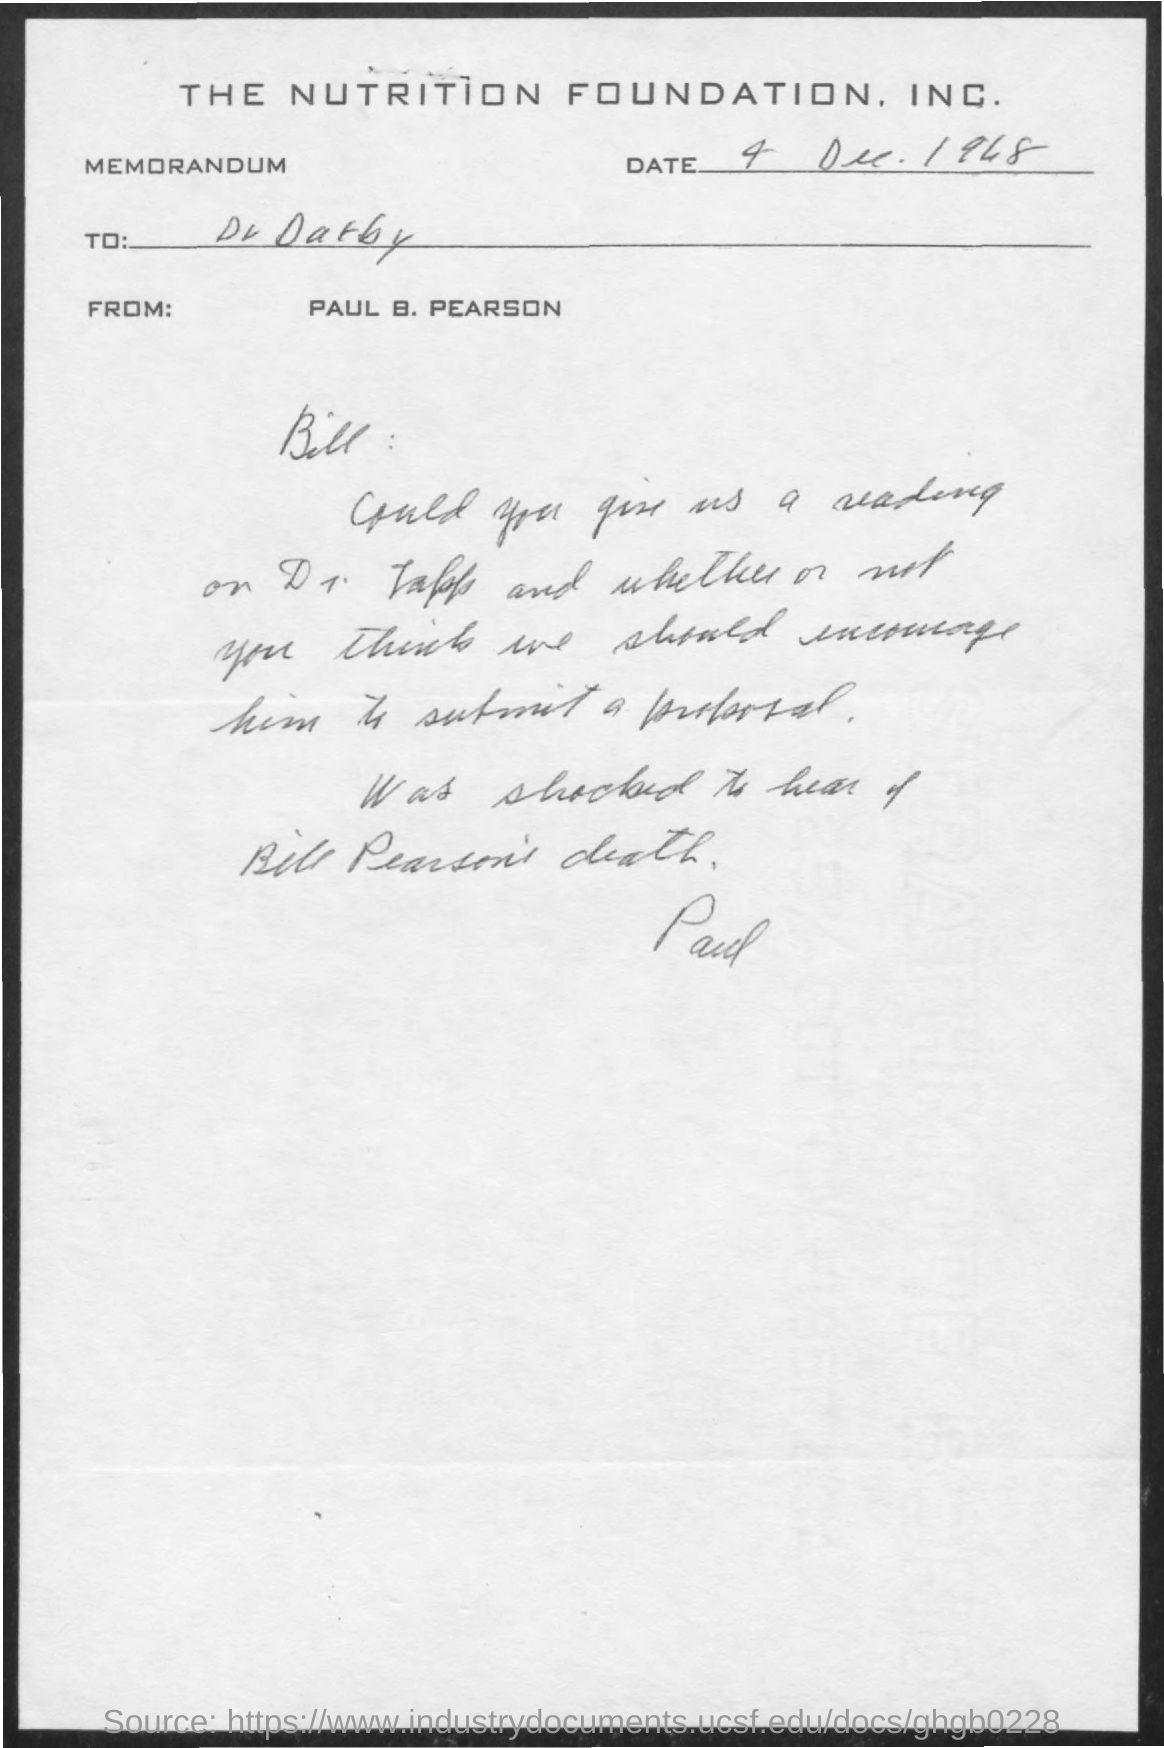Which company's memorandum is this?
Your answer should be compact. The Nutrition Foundation, Inc. What is the date mentioned in the memorandum?
Offer a terse response. 4 Dec. 1948. Who is the addressee of this memorandum?
Your response must be concise. Bill :. Who is the sender of this memorandum?
Your answer should be compact. PAUL B. PEARSON. 